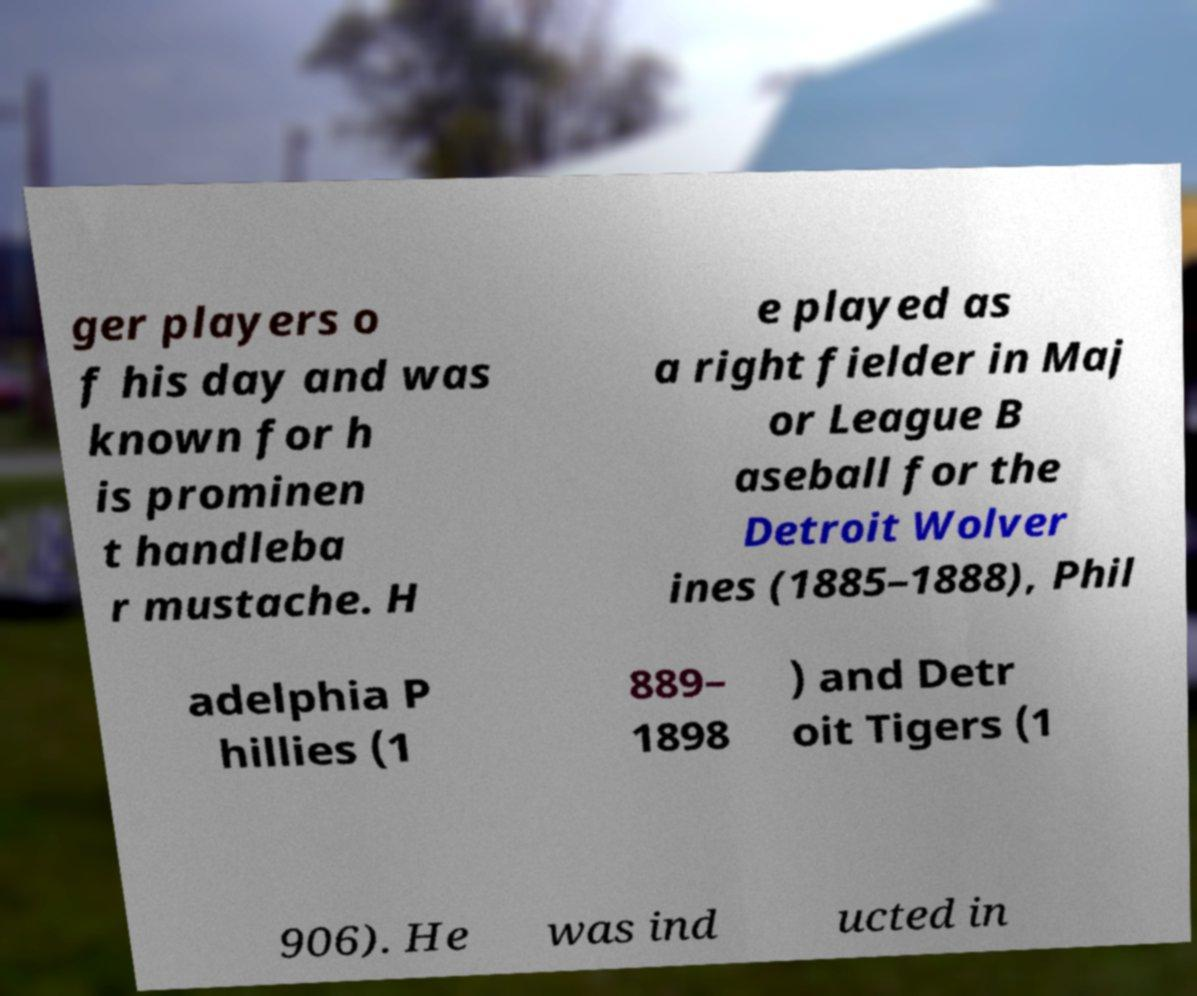Can you read and provide the text displayed in the image?This photo seems to have some interesting text. Can you extract and type it out for me? ger players o f his day and was known for h is prominen t handleba r mustache. H e played as a right fielder in Maj or League B aseball for the Detroit Wolver ines (1885–1888), Phil adelphia P hillies (1 889– 1898 ) and Detr oit Tigers (1 906). He was ind ucted in 